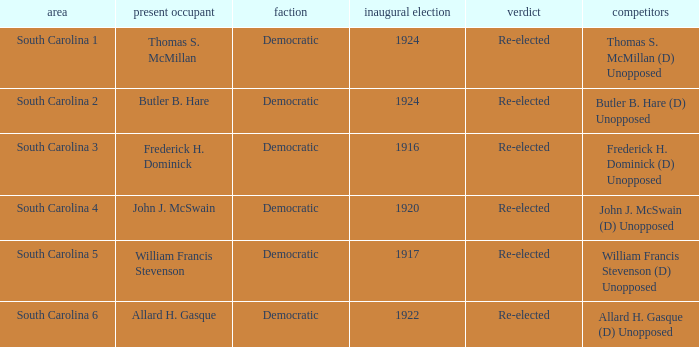What is the total number of results where the district is south carolina 5? 1.0. Would you be able to parse every entry in this table? {'header': ['area', 'present occupant', 'faction', 'inaugural election', 'verdict', 'competitors'], 'rows': [['South Carolina 1', 'Thomas S. McMillan', 'Democratic', '1924', 'Re-elected', 'Thomas S. McMillan (D) Unopposed'], ['South Carolina 2', 'Butler B. Hare', 'Democratic', '1924', 'Re-elected', 'Butler B. Hare (D) Unopposed'], ['South Carolina 3', 'Frederick H. Dominick', 'Democratic', '1916', 'Re-elected', 'Frederick H. Dominick (D) Unopposed'], ['South Carolina 4', 'John J. McSwain', 'Democratic', '1920', 'Re-elected', 'John J. McSwain (D) Unopposed'], ['South Carolina 5', 'William Francis Stevenson', 'Democratic', '1917', 'Re-elected', 'William Francis Stevenson (D) Unopposed'], ['South Carolina 6', 'Allard H. Gasque', 'Democratic', '1922', 'Re-elected', 'Allard H. Gasque (D) Unopposed']]} 